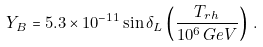Convert formula to latex. <formula><loc_0><loc_0><loc_500><loc_500>Y _ { B } = 5 . 3 \times 1 0 ^ { - 1 1 } \sin \delta _ { L } \left ( \frac { T _ { r h } } { 1 0 ^ { 6 } \, G e V } \right ) \, .</formula> 